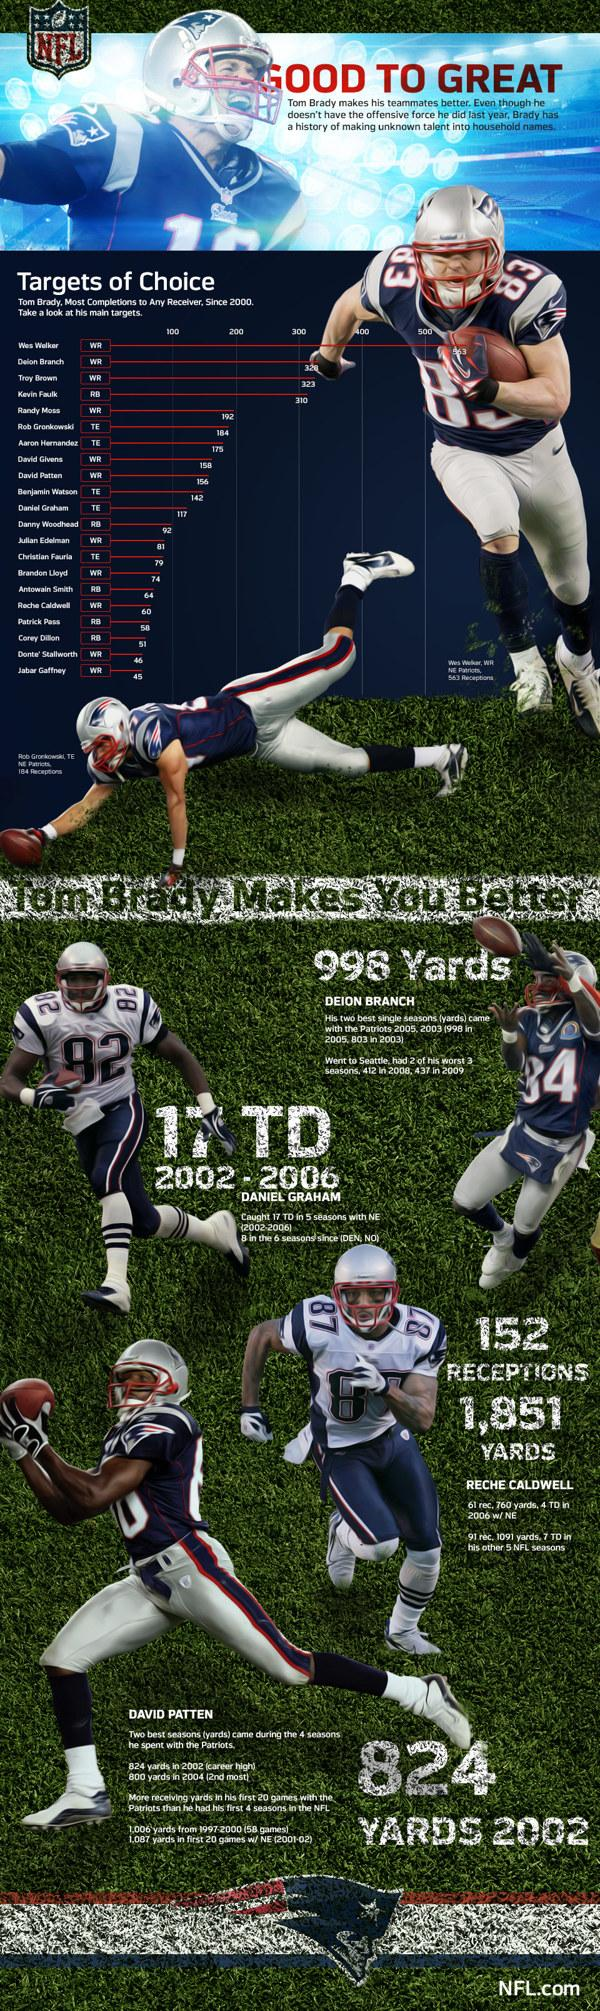Mention a couple of crucial points in this snapshot. The player to the right side of Daniel Graham is Deion Branch. The difference in most completions between Wes Walker and the person below him on the board is 235 completions. I, the speaker, do not know the jersey number of the player Daniel Graham. It is 82. The players in the document belong to the New England Patriots, Tampa Bay Buccaneers, or Minnesota Vikings. The team that the players belong to is the New England Patriots. 